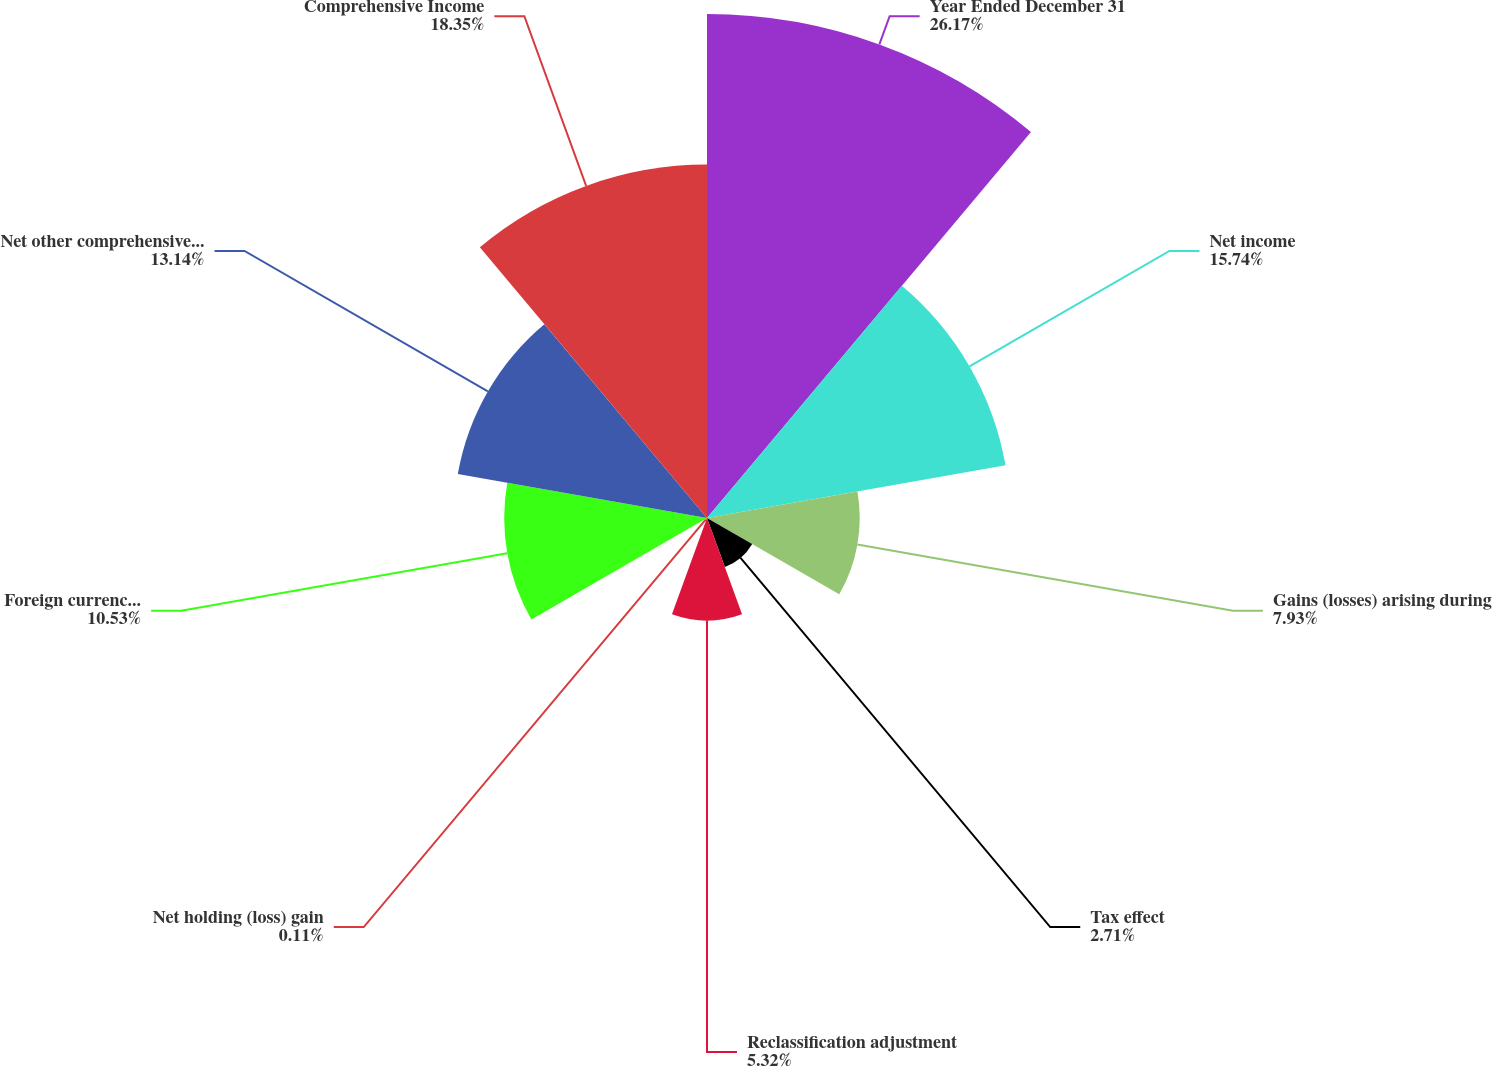<chart> <loc_0><loc_0><loc_500><loc_500><pie_chart><fcel>Year Ended December 31<fcel>Net income<fcel>Gains (losses) arising during<fcel>Tax effect<fcel>Reclassification adjustment<fcel>Net holding (loss) gain<fcel>Foreign currency translation<fcel>Net other comprehensive income<fcel>Comprehensive Income<nl><fcel>26.17%<fcel>15.74%<fcel>7.93%<fcel>2.71%<fcel>5.32%<fcel>0.11%<fcel>10.53%<fcel>13.14%<fcel>18.35%<nl></chart> 